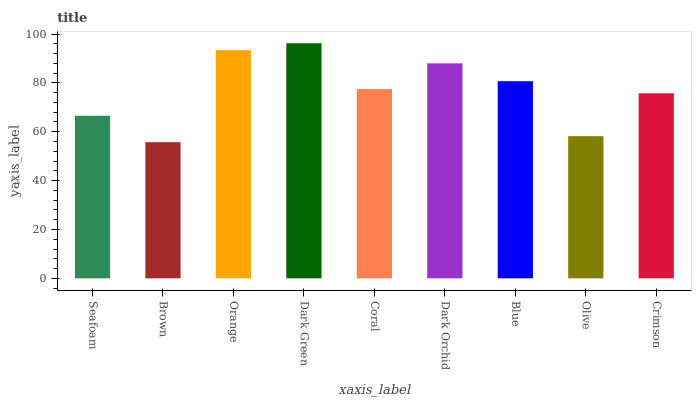Is Dark Green the maximum?
Answer yes or no. Yes. Is Orange the minimum?
Answer yes or no. No. Is Orange the maximum?
Answer yes or no. No. Is Orange greater than Brown?
Answer yes or no. Yes. Is Brown less than Orange?
Answer yes or no. Yes. Is Brown greater than Orange?
Answer yes or no. No. Is Orange less than Brown?
Answer yes or no. No. Is Coral the high median?
Answer yes or no. Yes. Is Coral the low median?
Answer yes or no. Yes. Is Brown the high median?
Answer yes or no. No. Is Brown the low median?
Answer yes or no. No. 